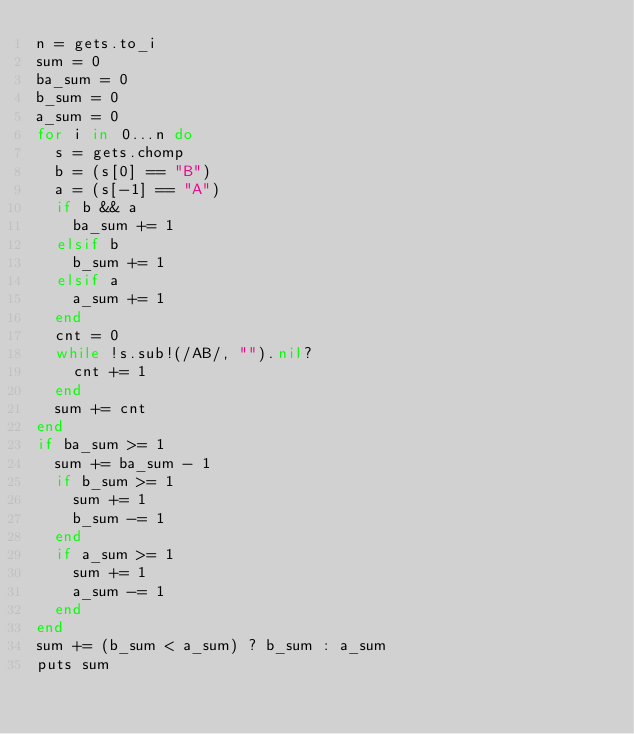<code> <loc_0><loc_0><loc_500><loc_500><_Ruby_>n = gets.to_i
sum = 0
ba_sum = 0
b_sum = 0
a_sum = 0
for i in 0...n do
  s = gets.chomp
  b = (s[0] == "B")
  a = (s[-1] == "A")
  if b && a
    ba_sum += 1
  elsif b
    b_sum += 1
  elsif a
    a_sum += 1
  end
  cnt = 0
  while !s.sub!(/AB/, "").nil?
    cnt += 1
  end
  sum += cnt
end
if ba_sum >= 1
  sum += ba_sum - 1
  if b_sum >= 1
    sum += 1
    b_sum -= 1
  end
  if a_sum >= 1
    sum += 1
    a_sum -= 1
  end
end
sum += (b_sum < a_sum) ? b_sum : a_sum
puts sum
</code> 